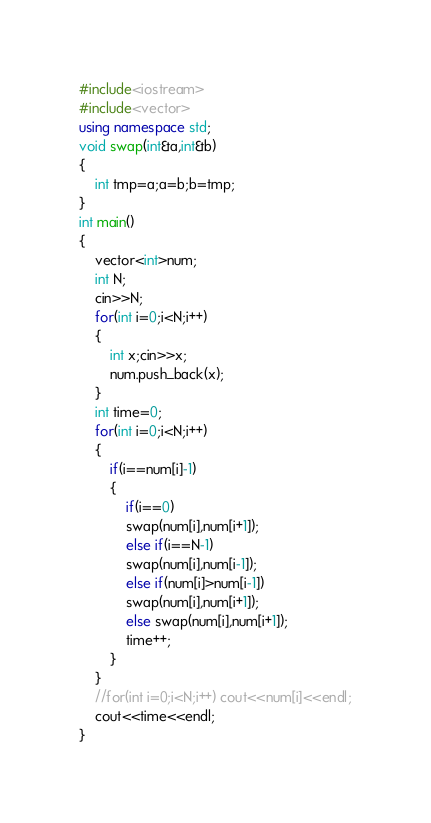<code> <loc_0><loc_0><loc_500><loc_500><_C++_>#include<iostream>
#include<vector>
using namespace std;
void swap(int&a,int&b)
{
	int tmp=a;a=b;b=tmp;
}
int main()
{
	vector<int>num;
	int N;
	cin>>N;
	for(int i=0;i<N;i++)
	{
		int x;cin>>x;
		num.push_back(x);
	}
	int time=0;
	for(int i=0;i<N;i++)
	{
		if(i==num[i]-1)
		{
			if(i==0)
			swap(num[i],num[i+1]);
			else if(i==N-1)
			swap(num[i],num[i-1]);
			else if(num[i]>num[i-1])
			swap(num[i],num[i+1]);
			else swap(num[i],num[i+1]);
			time++;
		}
	}
	//for(int i=0;i<N;i++) cout<<num[i]<<endl;
	cout<<time<<endl;
}</code> 